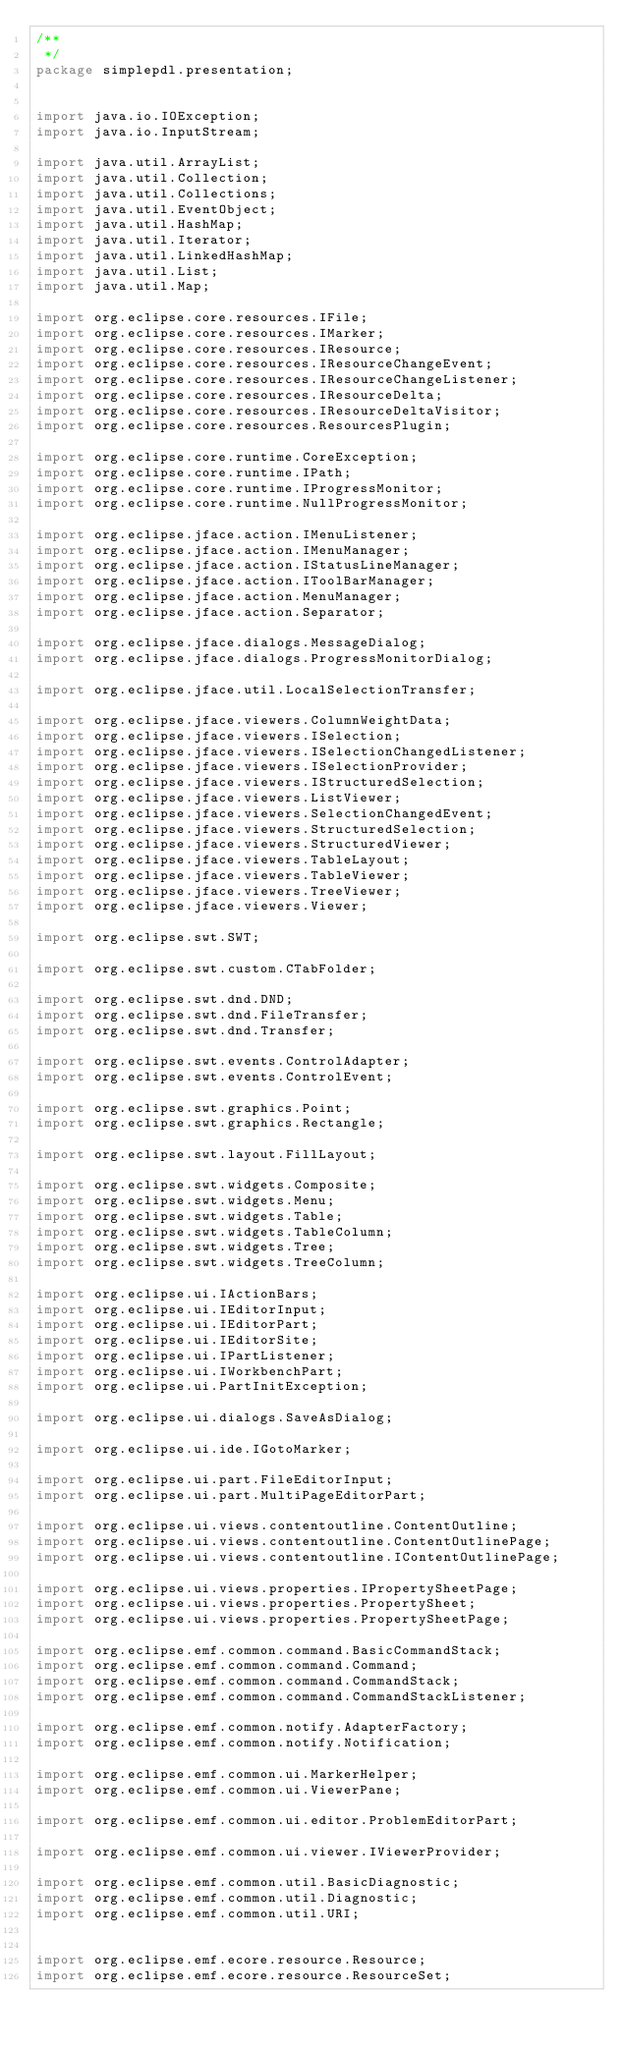<code> <loc_0><loc_0><loc_500><loc_500><_Java_>/**
 */
package simplepdl.presentation;


import java.io.IOException;
import java.io.InputStream;

import java.util.ArrayList;
import java.util.Collection;
import java.util.Collections;
import java.util.EventObject;
import java.util.HashMap;
import java.util.Iterator;
import java.util.LinkedHashMap;
import java.util.List;
import java.util.Map;

import org.eclipse.core.resources.IFile;
import org.eclipse.core.resources.IMarker;
import org.eclipse.core.resources.IResource;
import org.eclipse.core.resources.IResourceChangeEvent;
import org.eclipse.core.resources.IResourceChangeListener;
import org.eclipse.core.resources.IResourceDelta;
import org.eclipse.core.resources.IResourceDeltaVisitor;
import org.eclipse.core.resources.ResourcesPlugin;

import org.eclipse.core.runtime.CoreException;
import org.eclipse.core.runtime.IPath;
import org.eclipse.core.runtime.IProgressMonitor;
import org.eclipse.core.runtime.NullProgressMonitor;

import org.eclipse.jface.action.IMenuListener;
import org.eclipse.jface.action.IMenuManager;
import org.eclipse.jface.action.IStatusLineManager;
import org.eclipse.jface.action.IToolBarManager;
import org.eclipse.jface.action.MenuManager;
import org.eclipse.jface.action.Separator;

import org.eclipse.jface.dialogs.MessageDialog;
import org.eclipse.jface.dialogs.ProgressMonitorDialog;

import org.eclipse.jface.util.LocalSelectionTransfer;

import org.eclipse.jface.viewers.ColumnWeightData;
import org.eclipse.jface.viewers.ISelection;
import org.eclipse.jface.viewers.ISelectionChangedListener;
import org.eclipse.jface.viewers.ISelectionProvider;
import org.eclipse.jface.viewers.IStructuredSelection;
import org.eclipse.jface.viewers.ListViewer;
import org.eclipse.jface.viewers.SelectionChangedEvent;
import org.eclipse.jface.viewers.StructuredSelection;
import org.eclipse.jface.viewers.StructuredViewer;
import org.eclipse.jface.viewers.TableLayout;
import org.eclipse.jface.viewers.TableViewer;
import org.eclipse.jface.viewers.TreeViewer;
import org.eclipse.jface.viewers.Viewer;

import org.eclipse.swt.SWT;

import org.eclipse.swt.custom.CTabFolder;

import org.eclipse.swt.dnd.DND;
import org.eclipse.swt.dnd.FileTransfer;
import org.eclipse.swt.dnd.Transfer;

import org.eclipse.swt.events.ControlAdapter;
import org.eclipse.swt.events.ControlEvent;

import org.eclipse.swt.graphics.Point;
import org.eclipse.swt.graphics.Rectangle;

import org.eclipse.swt.layout.FillLayout;

import org.eclipse.swt.widgets.Composite;
import org.eclipse.swt.widgets.Menu;
import org.eclipse.swt.widgets.Table;
import org.eclipse.swt.widgets.TableColumn;
import org.eclipse.swt.widgets.Tree;
import org.eclipse.swt.widgets.TreeColumn;

import org.eclipse.ui.IActionBars;
import org.eclipse.ui.IEditorInput;
import org.eclipse.ui.IEditorPart;
import org.eclipse.ui.IEditorSite;
import org.eclipse.ui.IPartListener;
import org.eclipse.ui.IWorkbenchPart;
import org.eclipse.ui.PartInitException;

import org.eclipse.ui.dialogs.SaveAsDialog;

import org.eclipse.ui.ide.IGotoMarker;

import org.eclipse.ui.part.FileEditorInput;
import org.eclipse.ui.part.MultiPageEditorPart;

import org.eclipse.ui.views.contentoutline.ContentOutline;
import org.eclipse.ui.views.contentoutline.ContentOutlinePage;
import org.eclipse.ui.views.contentoutline.IContentOutlinePage;

import org.eclipse.ui.views.properties.IPropertySheetPage;
import org.eclipse.ui.views.properties.PropertySheet;
import org.eclipse.ui.views.properties.PropertySheetPage;

import org.eclipse.emf.common.command.BasicCommandStack;
import org.eclipse.emf.common.command.Command;
import org.eclipse.emf.common.command.CommandStack;
import org.eclipse.emf.common.command.CommandStackListener;

import org.eclipse.emf.common.notify.AdapterFactory;
import org.eclipse.emf.common.notify.Notification;

import org.eclipse.emf.common.ui.MarkerHelper;
import org.eclipse.emf.common.ui.ViewerPane;

import org.eclipse.emf.common.ui.editor.ProblemEditorPart;

import org.eclipse.emf.common.ui.viewer.IViewerProvider;

import org.eclipse.emf.common.util.BasicDiagnostic;
import org.eclipse.emf.common.util.Diagnostic;
import org.eclipse.emf.common.util.URI;


import org.eclipse.emf.ecore.resource.Resource;
import org.eclipse.emf.ecore.resource.ResourceSet;
</code> 